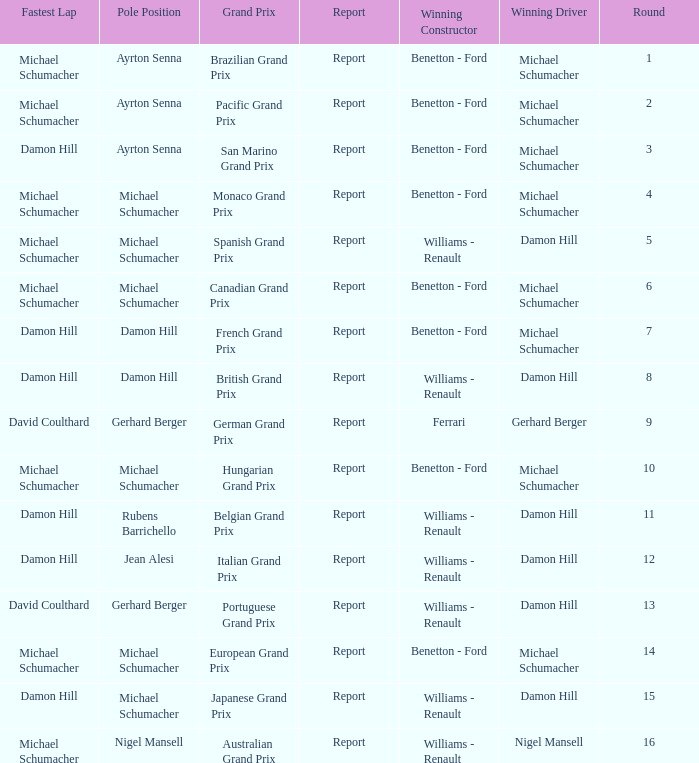Name the pole position at the japanese grand prix when the fastest lap is damon hill Michael Schumacher. 